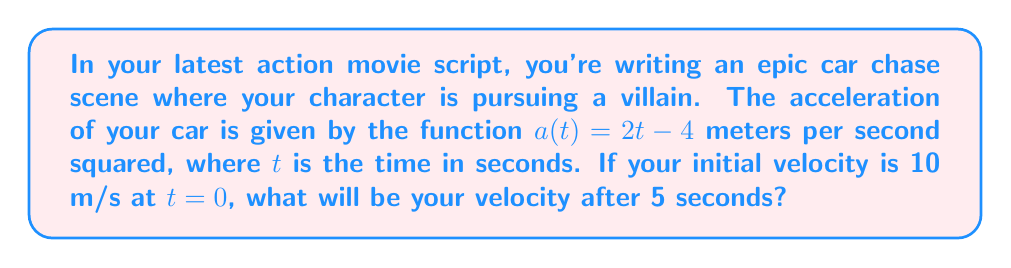Provide a solution to this math problem. Let's approach this step-by-step:

1) We're given the acceleration function $a(t) = 2t - 4$ and the initial velocity $v_0 = 10$ m/s.

2) To find the velocity at any time $t$, we need to integrate the acceleration function:

   $$v(t) = v_0 + \int_0^t a(t) dt$$

3) Let's solve this integral:

   $$v(t) = 10 + \int_0^t (2t - 4) dt$$
   $$v(t) = 10 + [t^2 - 4t]_0^t$$
   $$v(t) = 10 + (t^2 - 4t) - (0^2 - 4(0))$$
   $$v(t) = 10 + t^2 - 4t$$

4) Now we have the velocity function. To find the velocity at $t=5$ seconds, we simply substitute $t=5$ into this function:

   $$v(5) = 10 + 5^2 - 4(5)$$
   $$v(5) = 10 + 25 - 20$$
   $$v(5) = 15$$

Therefore, after 5 seconds, your velocity will be 15 m/s.
Answer: 15 m/s 